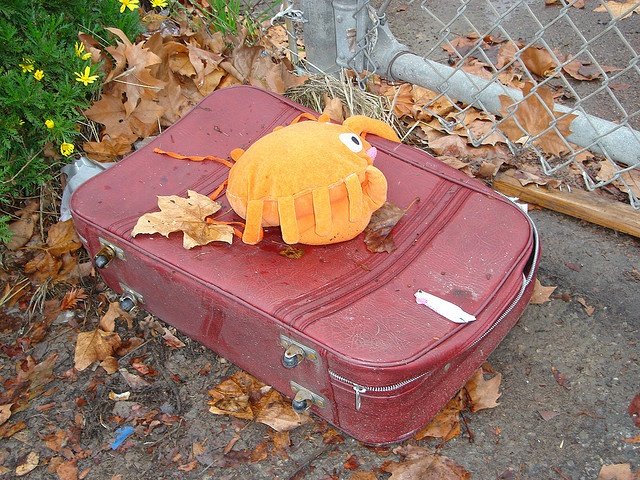Describe the objects in this image and their specific colors. I can see a suitcase in darkgreen, brown, salmon, and lightpink tones in this image. 